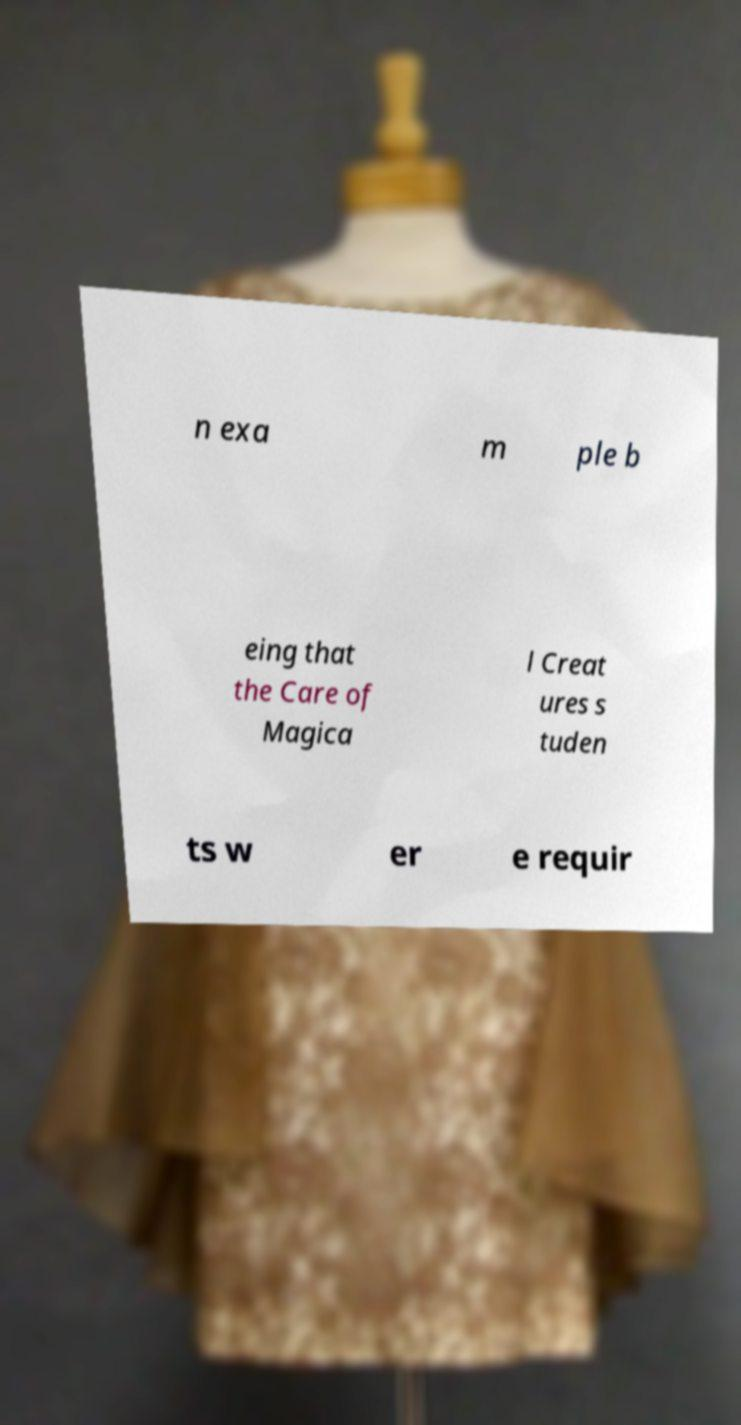There's text embedded in this image that I need extracted. Can you transcribe it verbatim? n exa m ple b eing that the Care of Magica l Creat ures s tuden ts w er e requir 